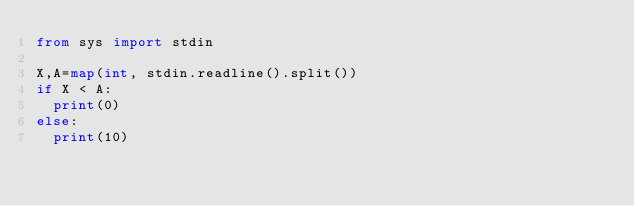<code> <loc_0><loc_0><loc_500><loc_500><_Python_>from sys import stdin

X,A=map(int, stdin.readline().split())
if X < A:
  print(0)
else:
  print(10)</code> 